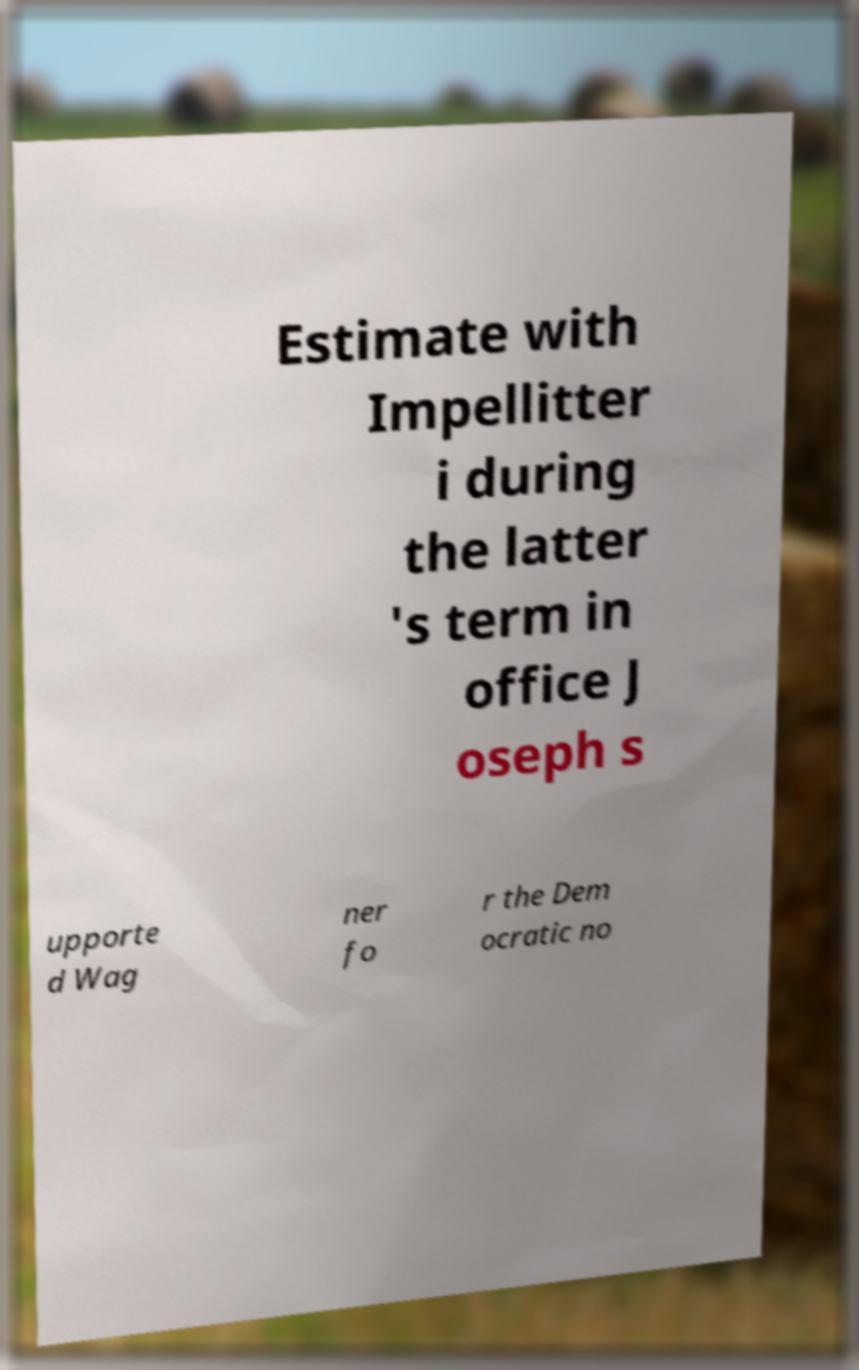For documentation purposes, I need the text within this image transcribed. Could you provide that? Estimate with Impellitter i during the latter 's term in office J oseph s upporte d Wag ner fo r the Dem ocratic no 